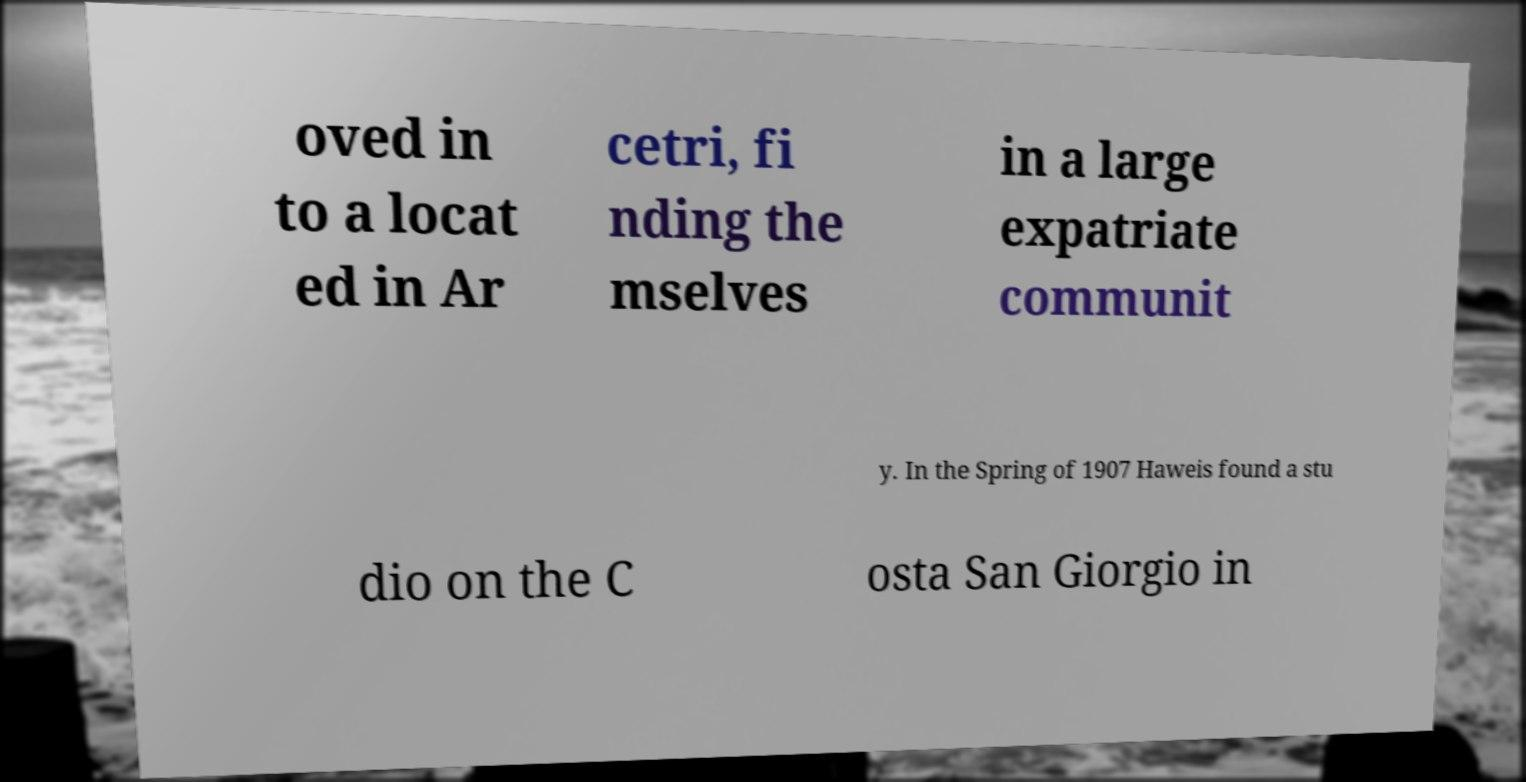For documentation purposes, I need the text within this image transcribed. Could you provide that? oved in to a locat ed in Ar cetri, fi nding the mselves in a large expatriate communit y. In the Spring of 1907 Haweis found a stu dio on the C osta San Giorgio in 